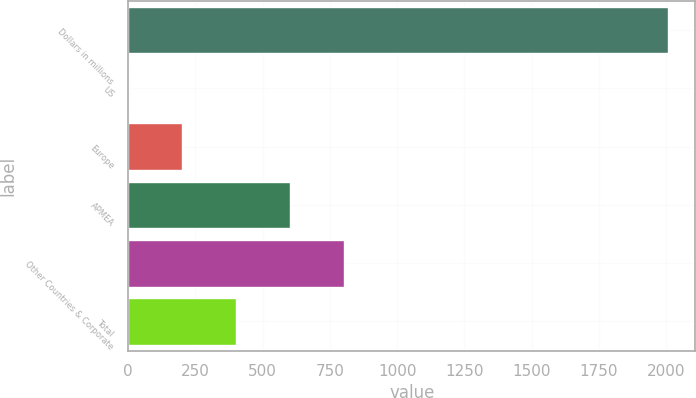Convert chart to OTSL. <chart><loc_0><loc_0><loc_500><loc_500><bar_chart><fcel>Dollars in millions<fcel>US<fcel>Europe<fcel>APMEA<fcel>Other Countries & Corporate<fcel>Total<nl><fcel>2008<fcel>1<fcel>201.7<fcel>603.1<fcel>803.8<fcel>402.4<nl></chart> 